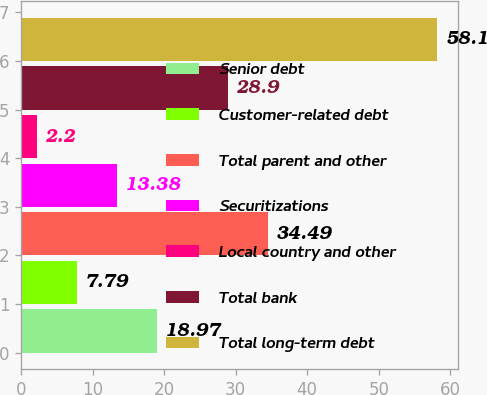Convert chart to OTSL. <chart><loc_0><loc_0><loc_500><loc_500><bar_chart><fcel>Senior debt<fcel>Customer-related debt<fcel>Total parent and other<fcel>Securitizations<fcel>Local country and other<fcel>Total bank<fcel>Total long-term debt<nl><fcel>18.97<fcel>7.79<fcel>34.49<fcel>13.38<fcel>2.2<fcel>28.9<fcel>58.1<nl></chart> 